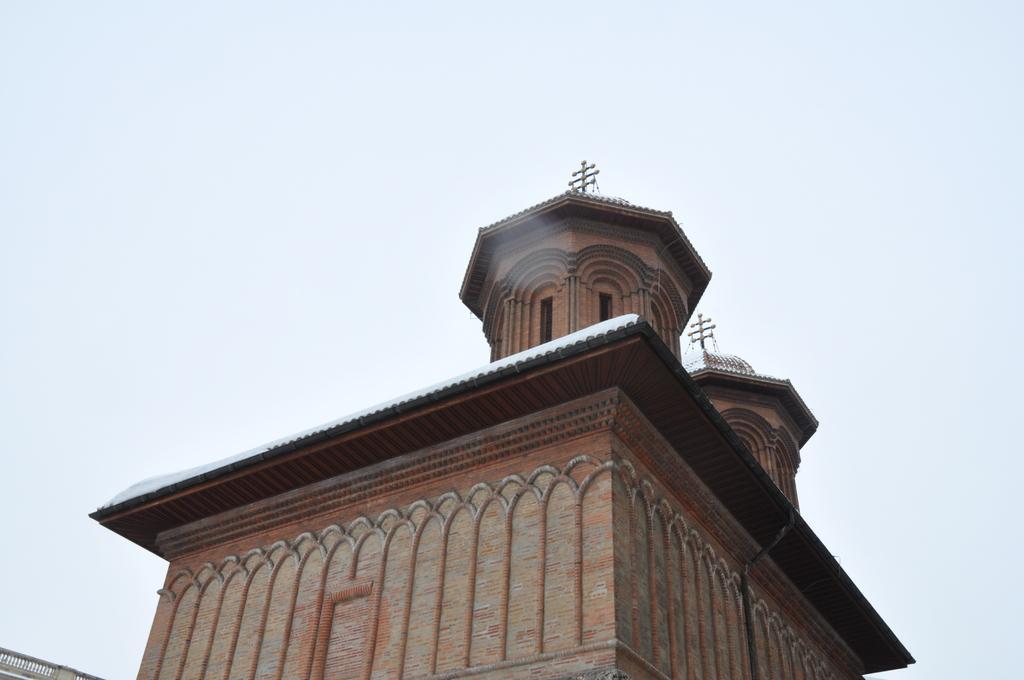Can you describe this image briefly? In the foreground of the picture there is a building. At the top it is sky. 